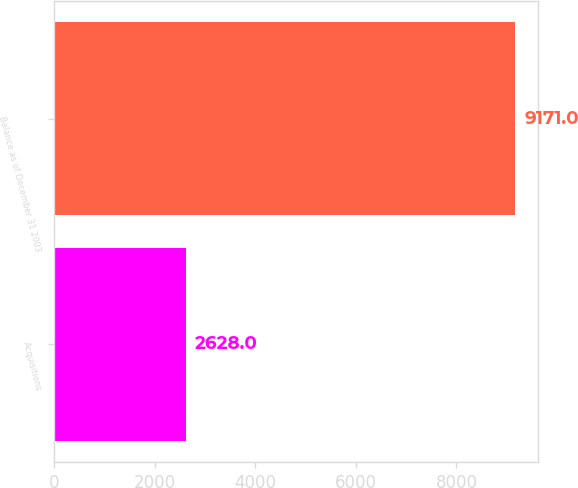Convert chart to OTSL. <chart><loc_0><loc_0><loc_500><loc_500><bar_chart><fcel>Acquisitions<fcel>Balance as of December 31 2003<nl><fcel>2628<fcel>9171<nl></chart> 